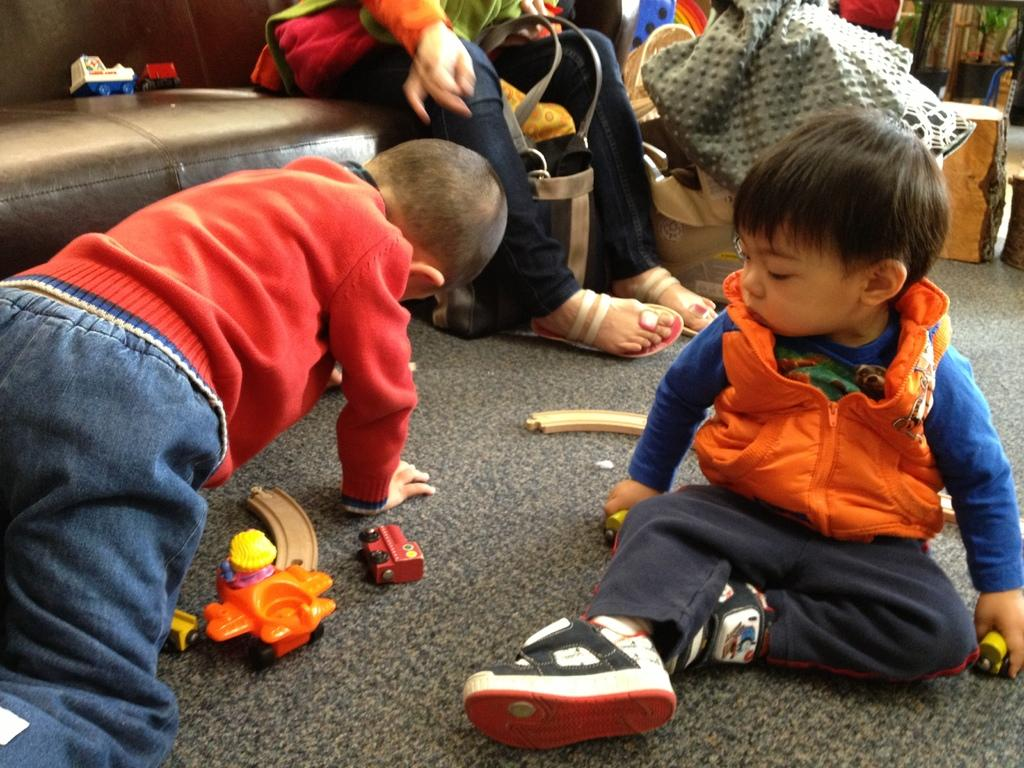What are the children in the image doing? The two children are playing with toys on the floor. Can you describe the person in the image? There is a person in the image, but their specific actions or characteristics are not mentioned in the facts. What else can be seen on the furniture in the image? There are two toys on the sofa. What other items are present in the image besides the children and toys? There are some clothes and objects in the image. What type of wine is being served in the image? There is no mention of wine or any beverage in the image. 